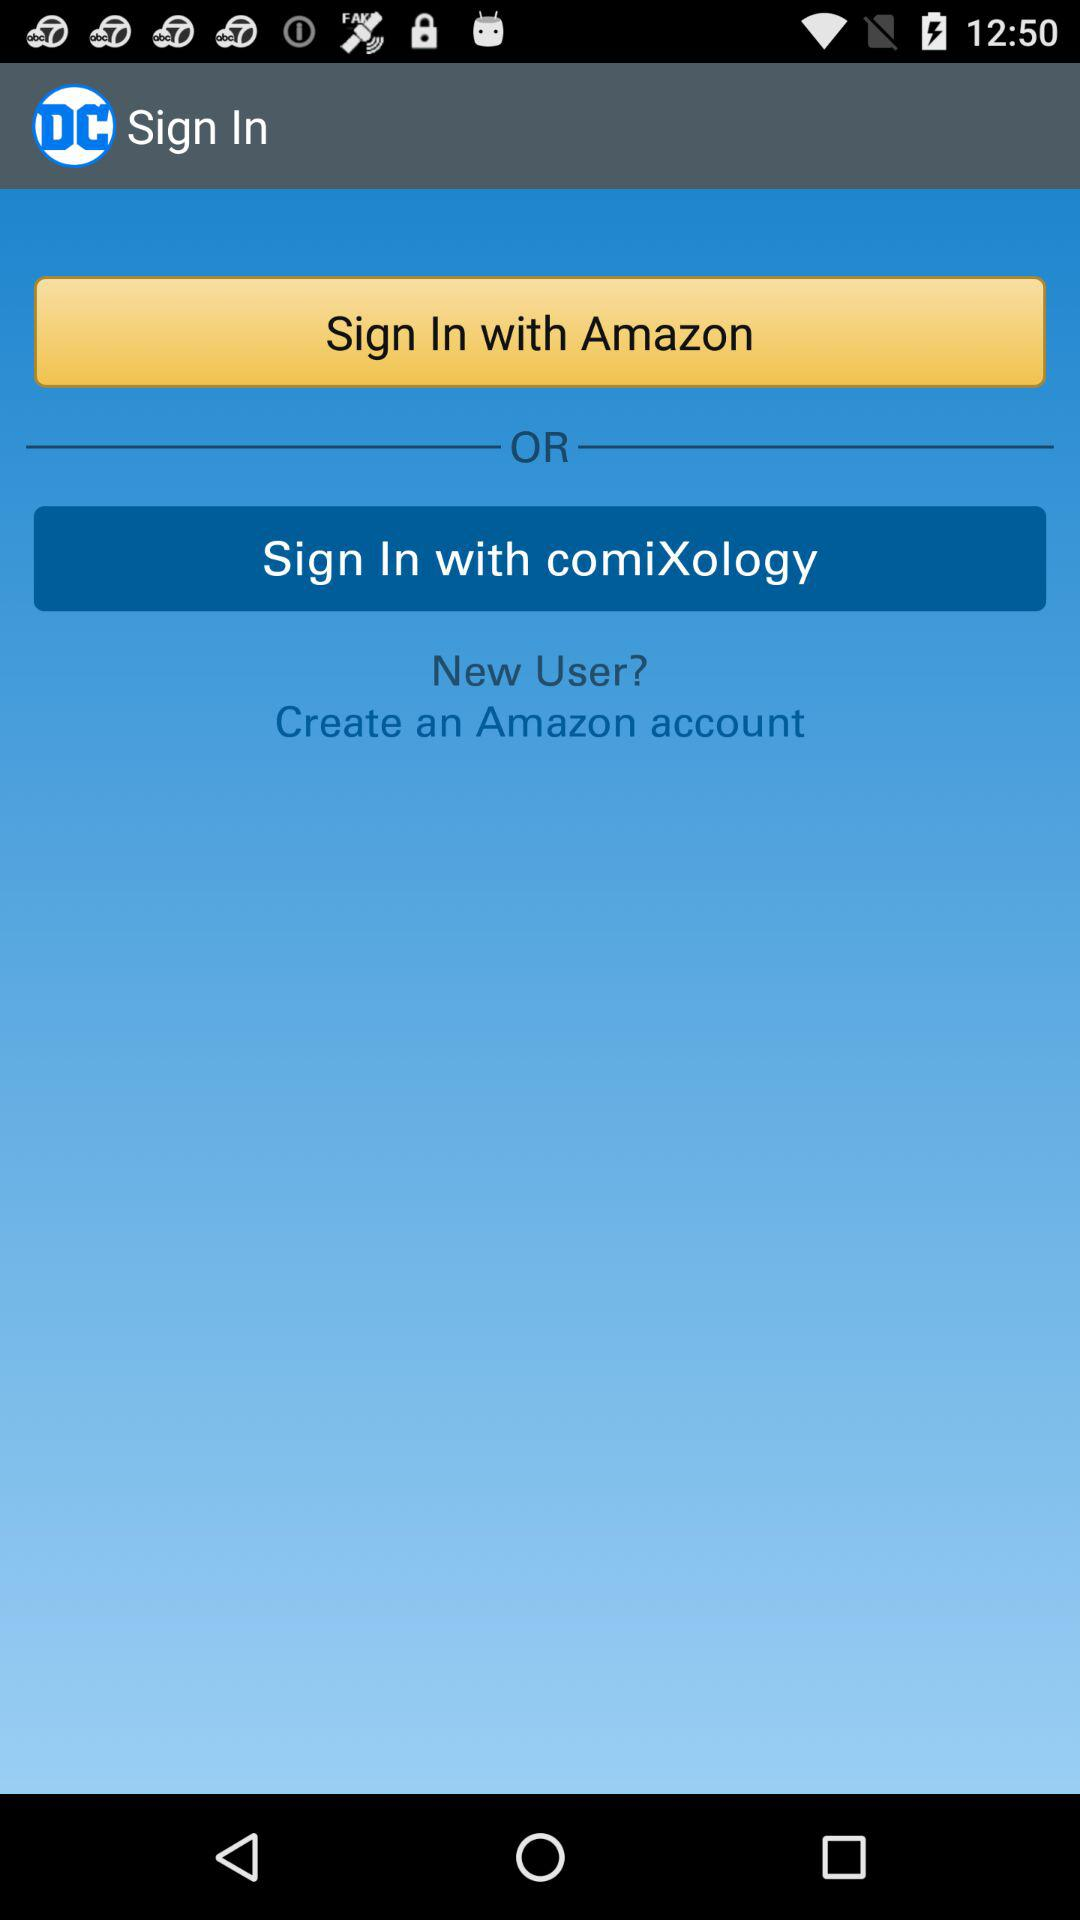Through which accounts can signing in be done? Signing in can be done through "Amazon" and "comiXology". 